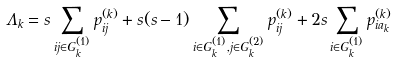<formula> <loc_0><loc_0><loc_500><loc_500>\Lambda _ { k } = s \sum _ { i j \in G _ { k } ^ { ( 1 ) } } p _ { i j } ^ { ( k ) } + s ( s - 1 ) \sum _ { i \in G _ { k } ^ { ( 1 ) } , j \in G _ { k } ^ { ( 2 ) } } p _ { i j } ^ { ( k ) } + 2 s \sum _ { i \in G _ { k } ^ { ( 1 ) } } p _ { i a _ { k } } ^ { ( k ) }</formula> 